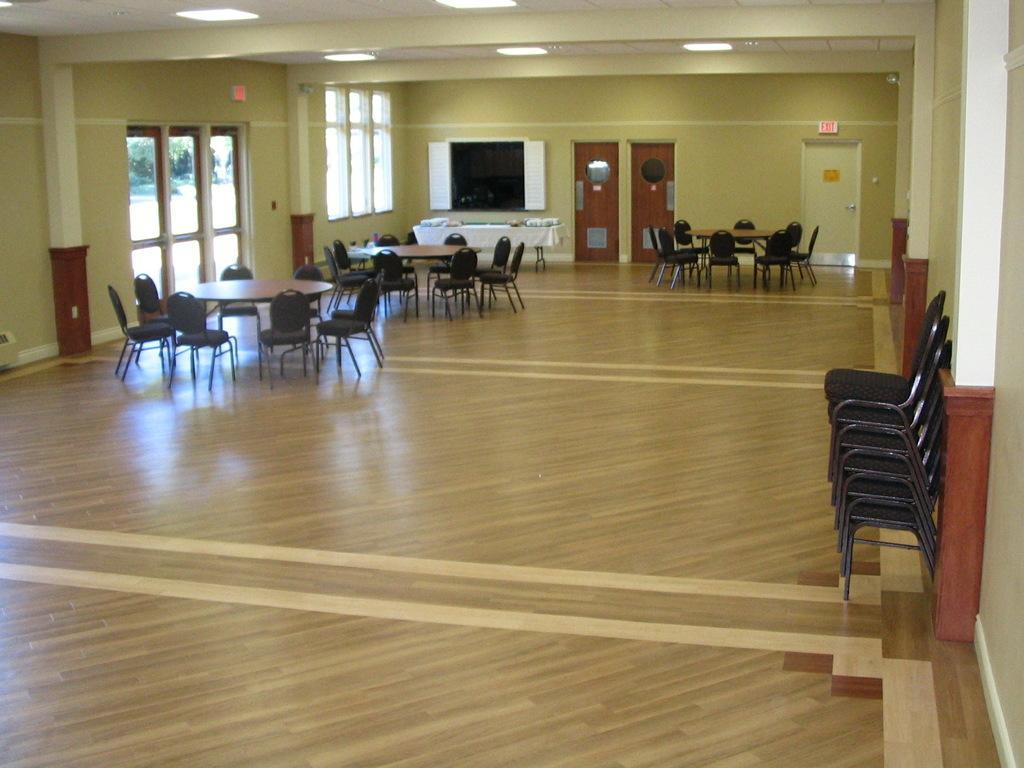Please provide a concise description of this image. This image is clicked inside a room. There are chairs and tables in the middle. There are lights at the top. There is a door on the right side. 